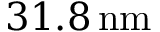Convert formula to latex. <formula><loc_0><loc_0><loc_500><loc_500>3 1 . 8 \, n m</formula> 